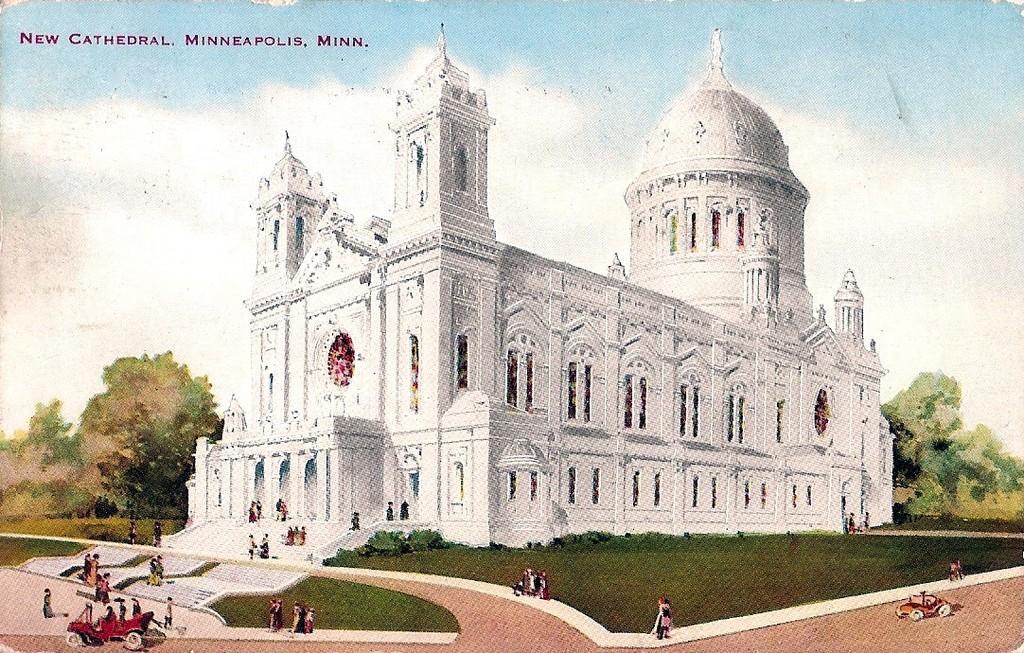Please provide a concise description of this image. In this image we can see a building, there are few people, vehicles, trees, grass and windows, in the background we can see the sky with clouds. 